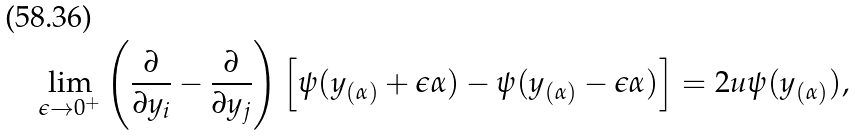<formula> <loc_0><loc_0><loc_500><loc_500>\lim _ { \epsilon \rightarrow 0 ^ { + } } \left ( \frac { \partial } { \partial y _ { i } } - \frac { \partial } { \partial y _ { j } } \right ) \left [ \psi ( y _ { ( \alpha ) } + \epsilon \alpha ) - \psi ( y _ { ( \alpha ) } - \epsilon \alpha ) \right ] = 2 u \psi ( y _ { ( \alpha ) } ) ,</formula> 